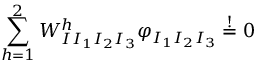<formula> <loc_0><loc_0><loc_500><loc_500>\sum _ { h = 1 } ^ { 2 } W _ { I I _ { 1 } I _ { 2 } I _ { 3 } } ^ { h } \varphi _ { I _ { 1 } I _ { 2 } I _ { 3 } } \stackrel { ! } { = } 0</formula> 